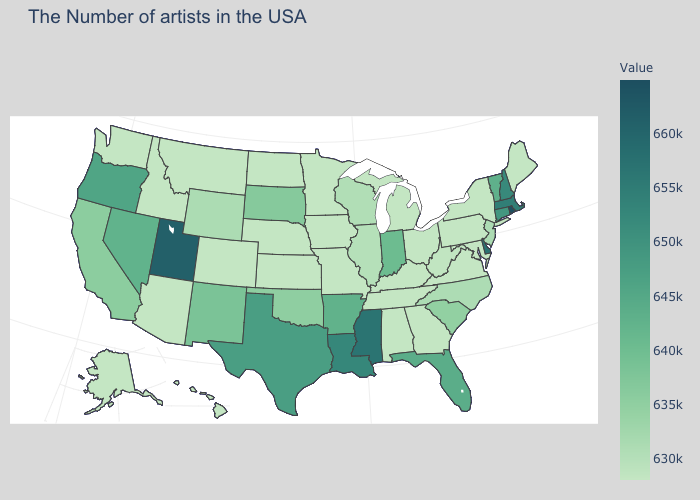Does Michigan have the highest value in the MidWest?
Answer briefly. No. Does Oregon have a higher value than Utah?
Keep it brief. No. 